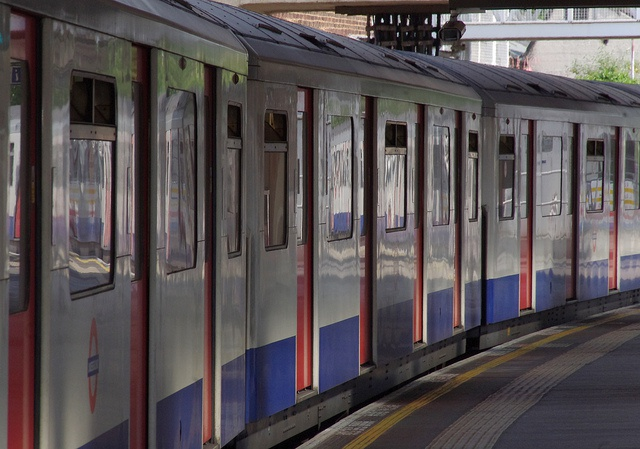Describe the objects in this image and their specific colors. I can see a train in gray, black, darkgray, and maroon tones in this image. 